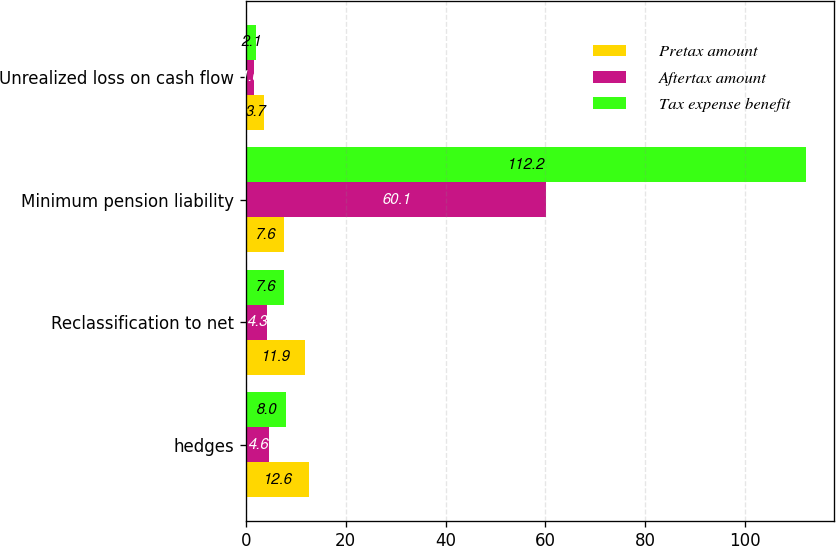Convert chart. <chart><loc_0><loc_0><loc_500><loc_500><stacked_bar_chart><ecel><fcel>hedges<fcel>Reclassification to net<fcel>Minimum pension liability<fcel>Unrealized loss on cash flow<nl><fcel>Pretax amount<fcel>12.6<fcel>11.9<fcel>7.6<fcel>3.7<nl><fcel>Aftertax amount<fcel>4.6<fcel>4.3<fcel>60.1<fcel>1.6<nl><fcel>Tax expense benefit<fcel>8<fcel>7.6<fcel>112.2<fcel>2.1<nl></chart> 